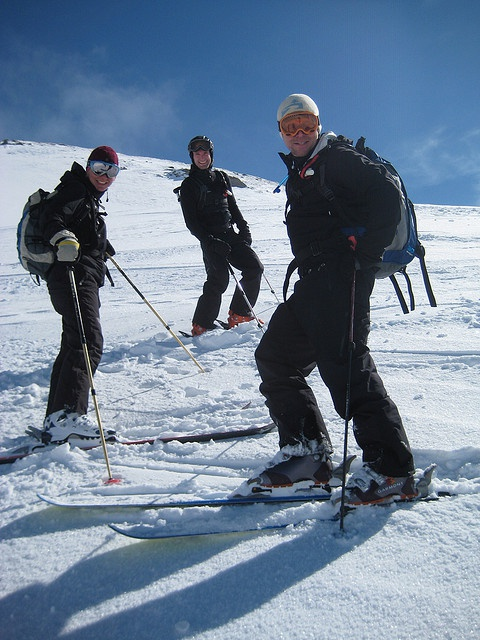Describe the objects in this image and their specific colors. I can see people in darkblue, black, gray, and navy tones, people in darkblue, black, gray, and lightgray tones, skis in darkblue, gray, and lightgray tones, people in darkblue, black, gray, maroon, and lightgray tones, and backpack in darkblue, black, navy, gray, and blue tones in this image. 